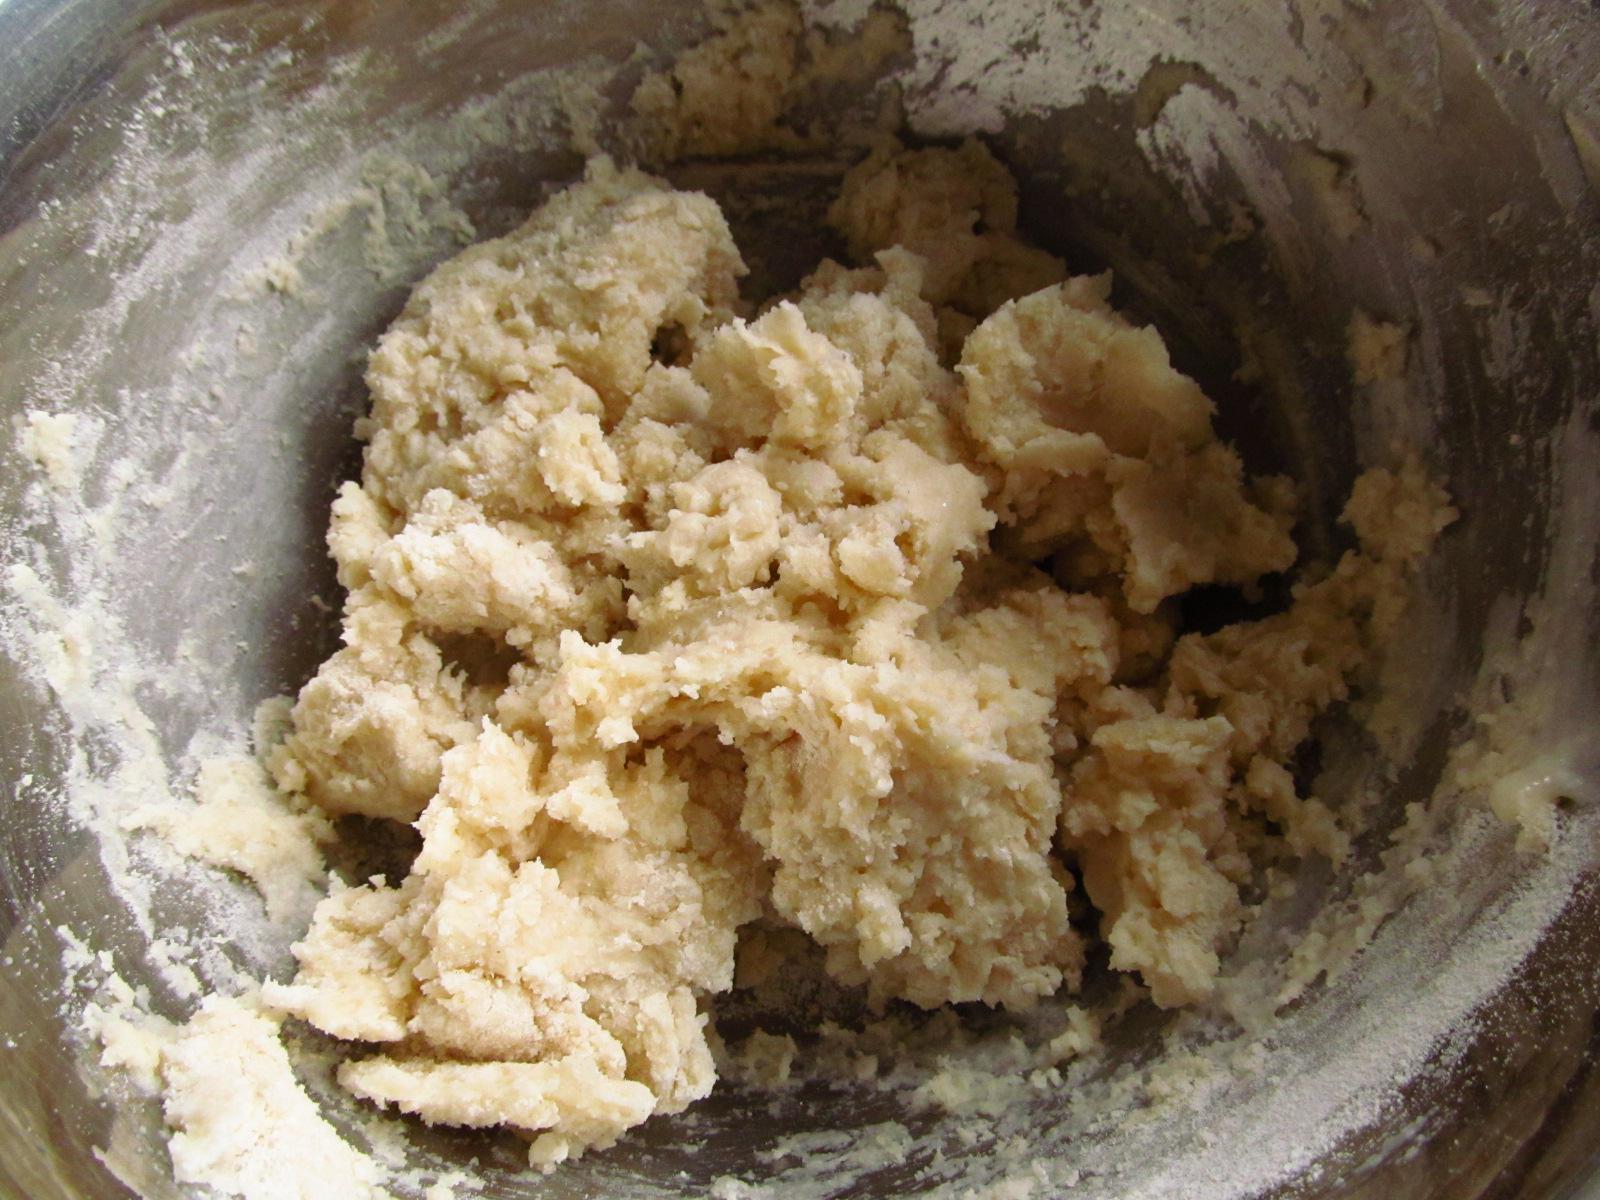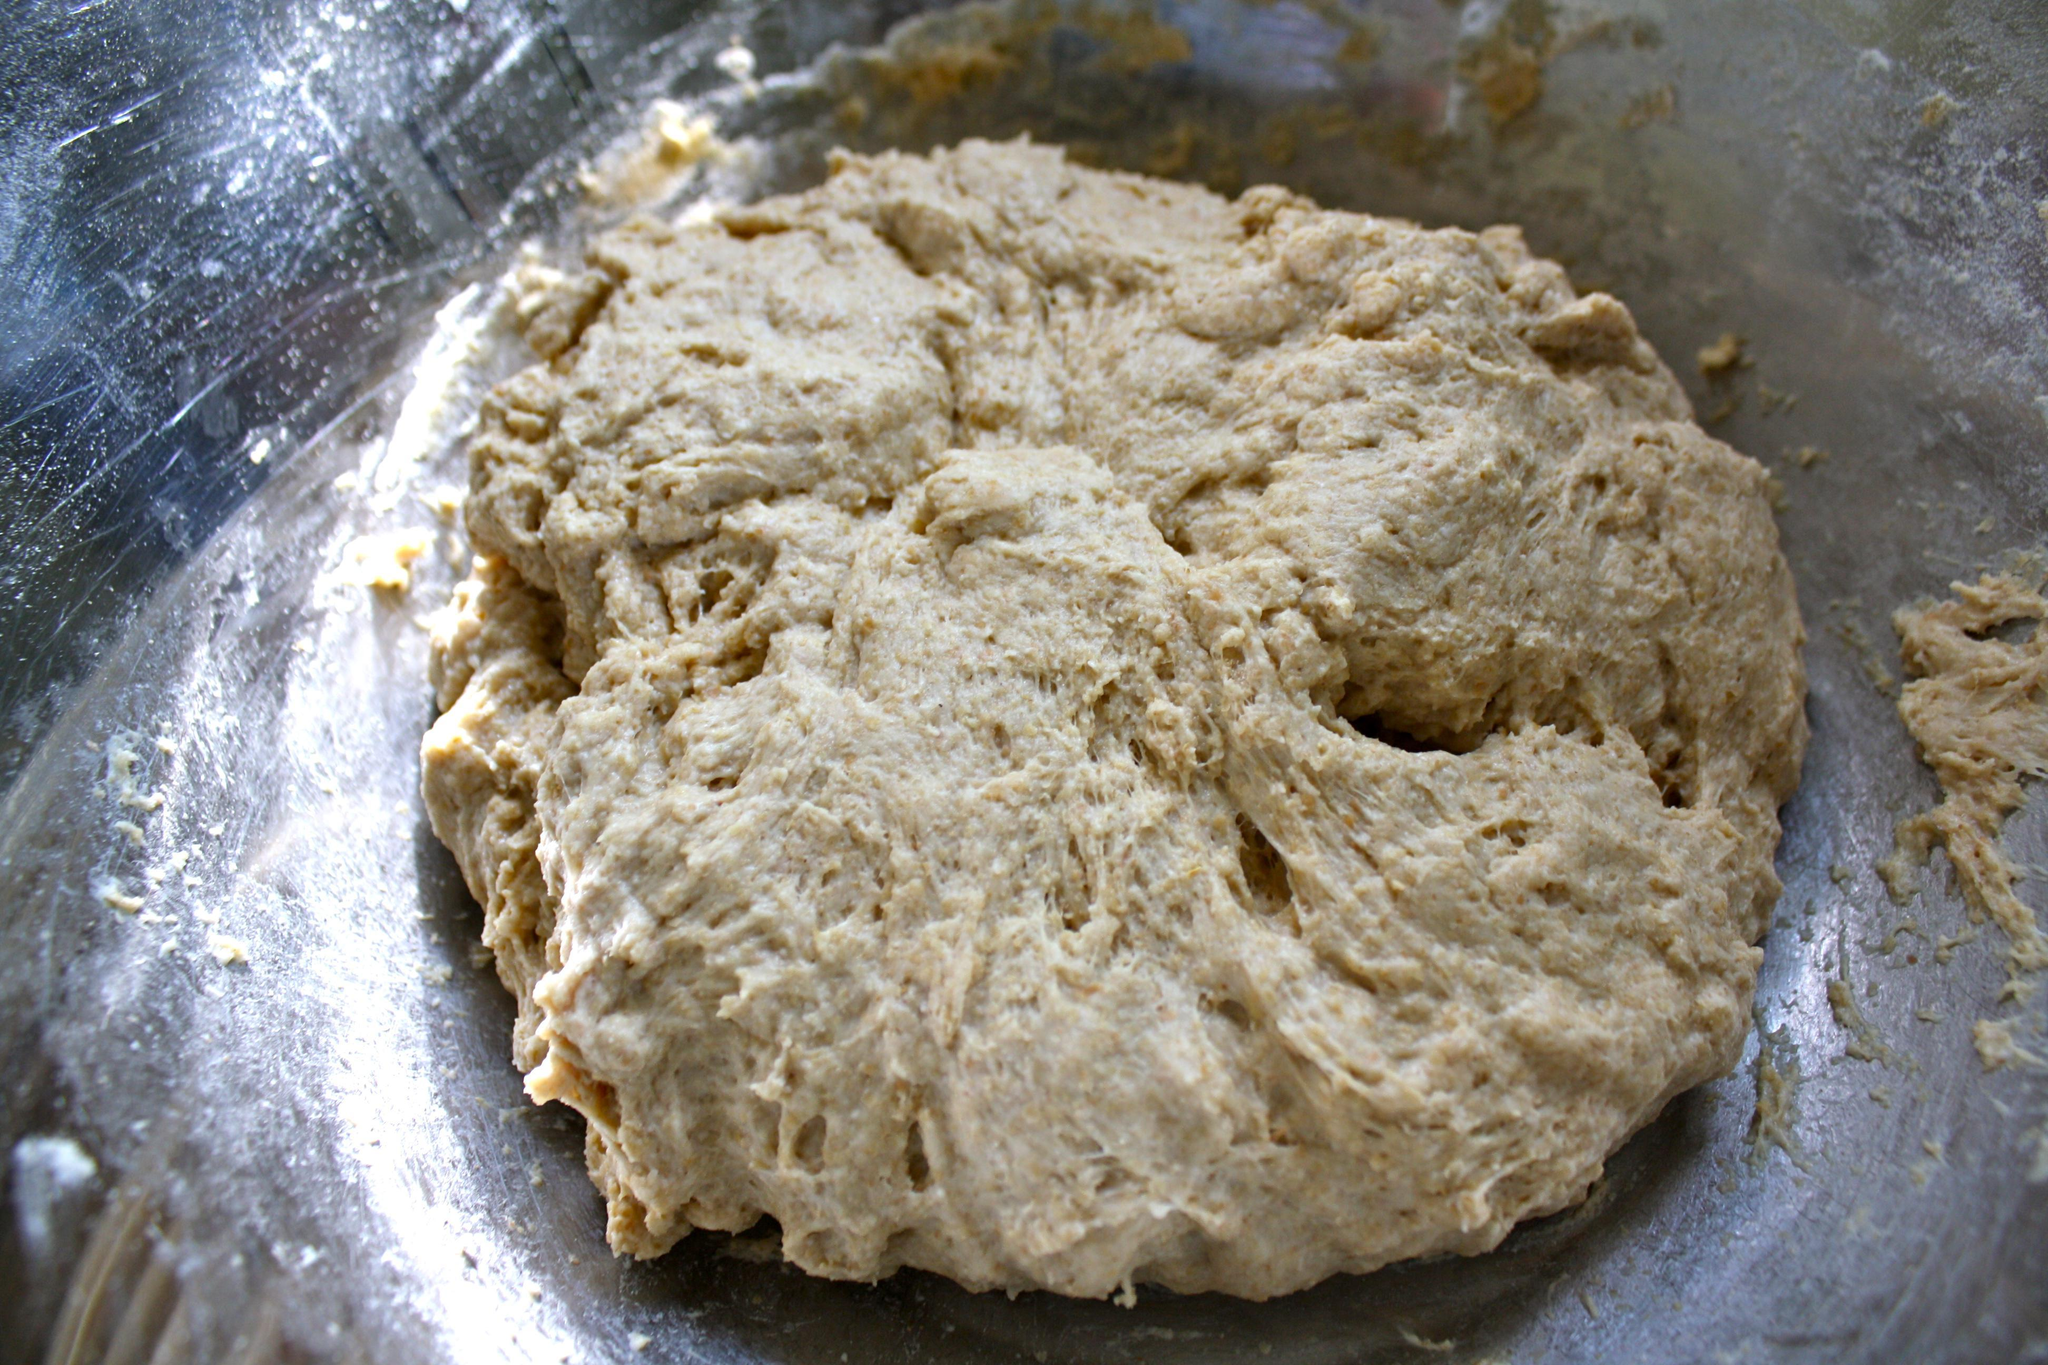The first image is the image on the left, the second image is the image on the right. Analyze the images presented: Is the assertion "Both images show unfinished cookie dough with chocolate chips." valid? Answer yes or no. No. The first image is the image on the left, the second image is the image on the right. For the images shown, is this caption "The image on the right contains a bowl of cookie dough with a wooden spoon in it." true? Answer yes or no. No. 